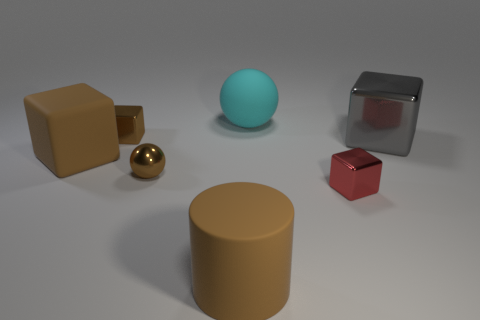What materials do the objects in the image seem to be made of based on their appearance? The objects appear to be made of various materials. The golden sphere and the red cube suggest a metallic sheen, implying they could be made of polished metal. The large tan cylinder and the larger cube have more of a matte finish, which could be indicative of a plastic or painted wood surface, and the smaller tan cube shares this characteristic. The sphere in the center has a smooth and slightly reflective surface that might be a type of rubber or plastic. 